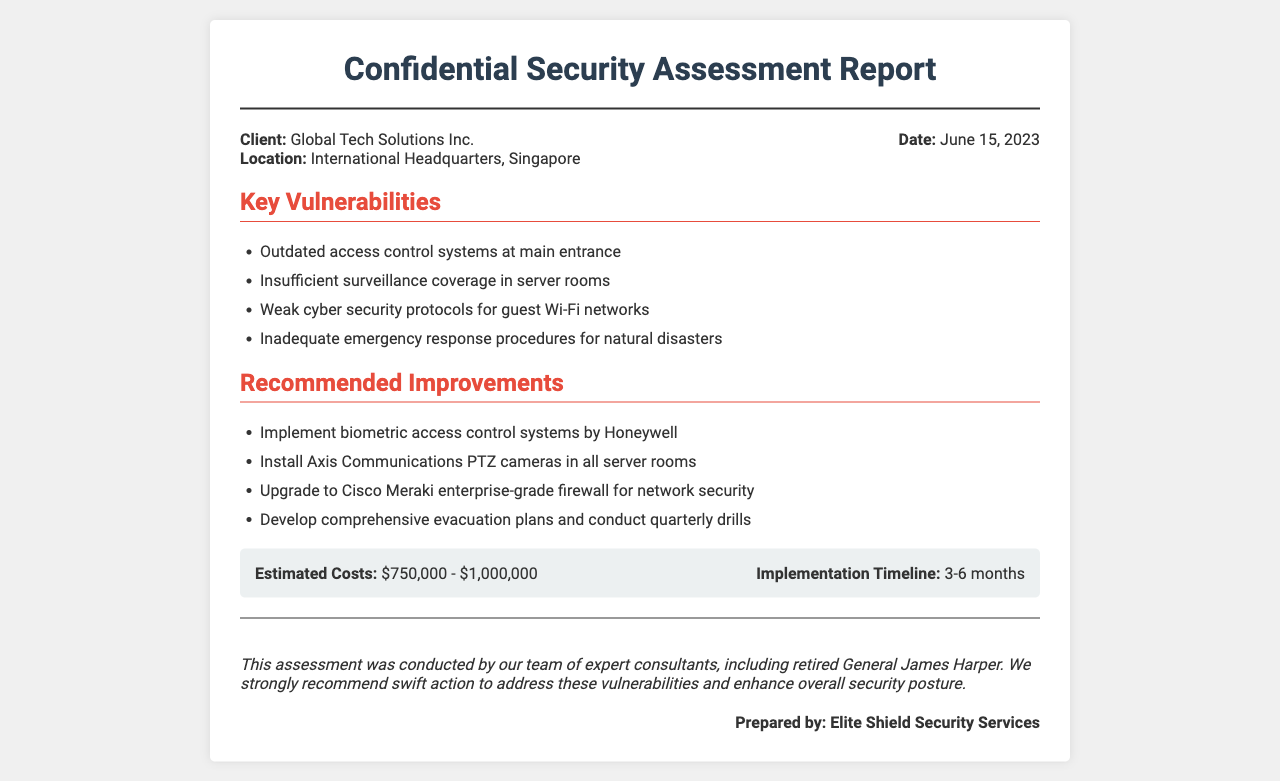What is the client’s name? The client's name is mentioned in the header of the report.
Answer: Global Tech Solutions Inc What is the location of the headquarters? The location of the headquarters is specified in the document.
Answer: International Headquarters, Singapore What is the date of the report? The date is included in the meta-info section of the fax.
Answer: June 15, 2023 How many key vulnerabilities are identified? The vulnerabilities are listed in a bullet point format in the document.
Answer: Four What is the estimated cost range for the recommended improvements? The estimated costs are provided in the cost-timeline section of the document.
Answer: $750,000 - $1,000,000 What is one recommended improvement for access control? The recommendations specifically include improvements related to access control.
Answer: Implement biometric access control systems by Honeywell Which company is recommended for network security upgrades? The document lists a specific company for upgrading network security.
Answer: Cisco Meraki Who conducted the assessment? The name of the person who conducted the assessment is mentioned towards the end of the document.
Answer: Retired General James Harper What is the implementation timeline for the recommendations? The implementation timeline is mentioned alongside estimated costs in the document.
Answer: 3-6 months 